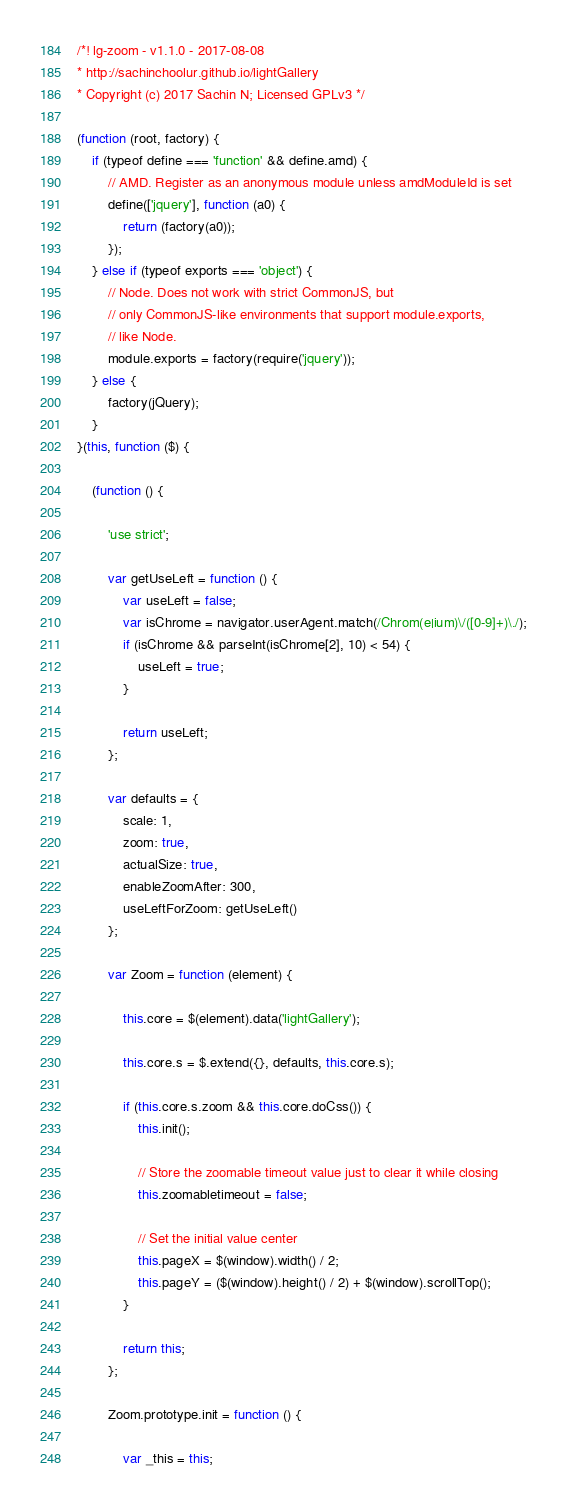Convert code to text. <code><loc_0><loc_0><loc_500><loc_500><_JavaScript_>/*! lg-zoom - v1.1.0 - 2017-08-08
* http://sachinchoolur.github.io/lightGallery
* Copyright (c) 2017 Sachin N; Licensed GPLv3 */

(function (root, factory) {
    if (typeof define === 'function' && define.amd) {
        // AMD. Register as an anonymous module unless amdModuleId is set
        define(['jquery'], function (a0) {
            return (factory(a0));
        });
    } else if (typeof exports === 'object') {
        // Node. Does not work with strict CommonJS, but
        // only CommonJS-like environments that support module.exports,
        // like Node.
        module.exports = factory(require('jquery'));
    } else {
        factory(jQuery);
    }
}(this, function ($) {

    (function () {

        'use strict';

        var getUseLeft = function () {
            var useLeft = false;
            var isChrome = navigator.userAgent.match(/Chrom(e|ium)\/([0-9]+)\./);
            if (isChrome && parseInt(isChrome[2], 10) < 54) {
                useLeft = true;
            }

            return useLeft;
        };

        var defaults = {
            scale: 1,
            zoom: true,
            actualSize: true,
            enableZoomAfter: 300,
            useLeftForZoom: getUseLeft()
        };

        var Zoom = function (element) {

            this.core = $(element).data('lightGallery');

            this.core.s = $.extend({}, defaults, this.core.s);

            if (this.core.s.zoom && this.core.doCss()) {
                this.init();

                // Store the zoomable timeout value just to clear it while closing
                this.zoomabletimeout = false;

                // Set the initial value center
                this.pageX = $(window).width() / 2;
                this.pageY = ($(window).height() / 2) + $(window).scrollTop();
            }

            return this;
        };

        Zoom.prototype.init = function () {

            var _this = this;</code> 